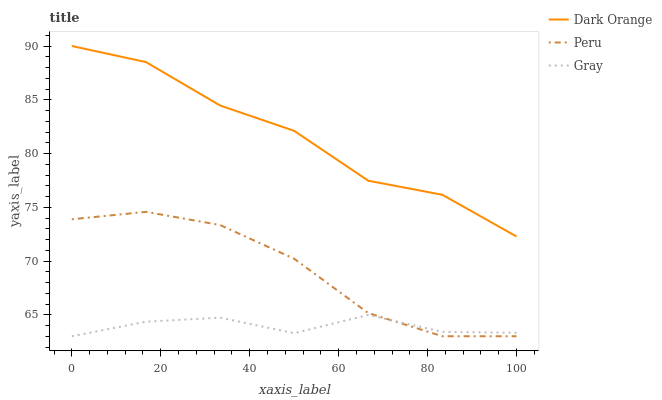Does Peru have the minimum area under the curve?
Answer yes or no. No. Does Peru have the maximum area under the curve?
Answer yes or no. No. Is Peru the smoothest?
Answer yes or no. No. Is Peru the roughest?
Answer yes or no. No. Does Peru have the highest value?
Answer yes or no. No. Is Gray less than Dark Orange?
Answer yes or no. Yes. Is Dark Orange greater than Gray?
Answer yes or no. Yes. Does Gray intersect Dark Orange?
Answer yes or no. No. 